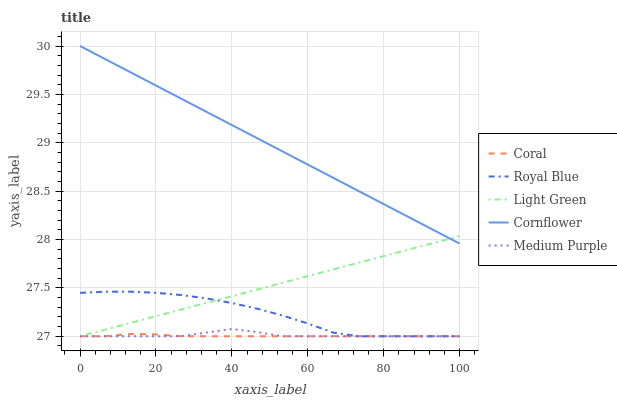Does Coral have the minimum area under the curve?
Answer yes or no. Yes. Does Cornflower have the maximum area under the curve?
Answer yes or no. Yes. Does Royal Blue have the minimum area under the curve?
Answer yes or no. No. Does Royal Blue have the maximum area under the curve?
Answer yes or no. No. Is Cornflower the smoothest?
Answer yes or no. Yes. Is Royal Blue the roughest?
Answer yes or no. Yes. Is Coral the smoothest?
Answer yes or no. No. Is Coral the roughest?
Answer yes or no. No. Does Medium Purple have the lowest value?
Answer yes or no. Yes. Does Cornflower have the lowest value?
Answer yes or no. No. Does Cornflower have the highest value?
Answer yes or no. Yes. Does Royal Blue have the highest value?
Answer yes or no. No. Is Medium Purple less than Cornflower?
Answer yes or no. Yes. Is Cornflower greater than Medium Purple?
Answer yes or no. Yes. Does Light Green intersect Medium Purple?
Answer yes or no. Yes. Is Light Green less than Medium Purple?
Answer yes or no. No. Is Light Green greater than Medium Purple?
Answer yes or no. No. Does Medium Purple intersect Cornflower?
Answer yes or no. No. 